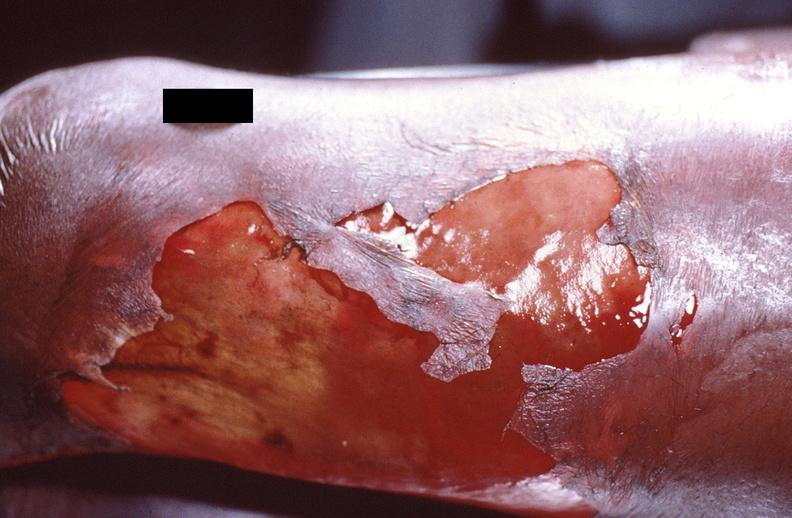does this image show panniculitis and fascitis?
Answer the question using a single word or phrase. Yes 